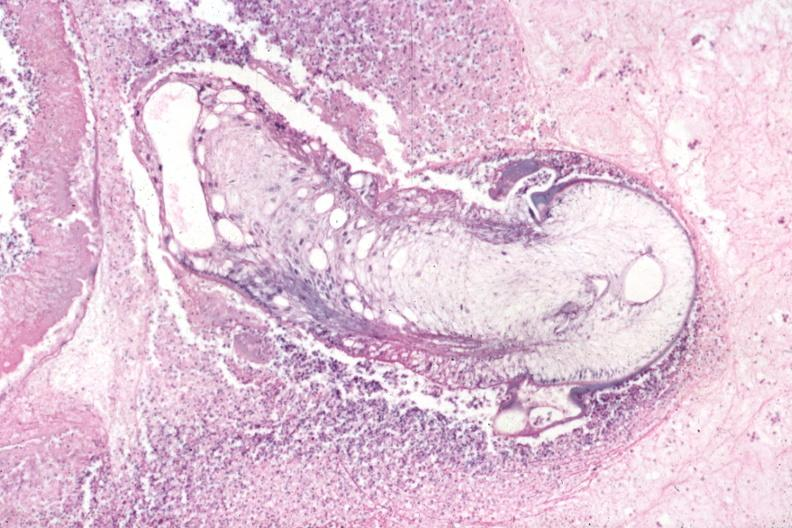s myocardial infarct present?
Answer the question using a single word or phrase. No 